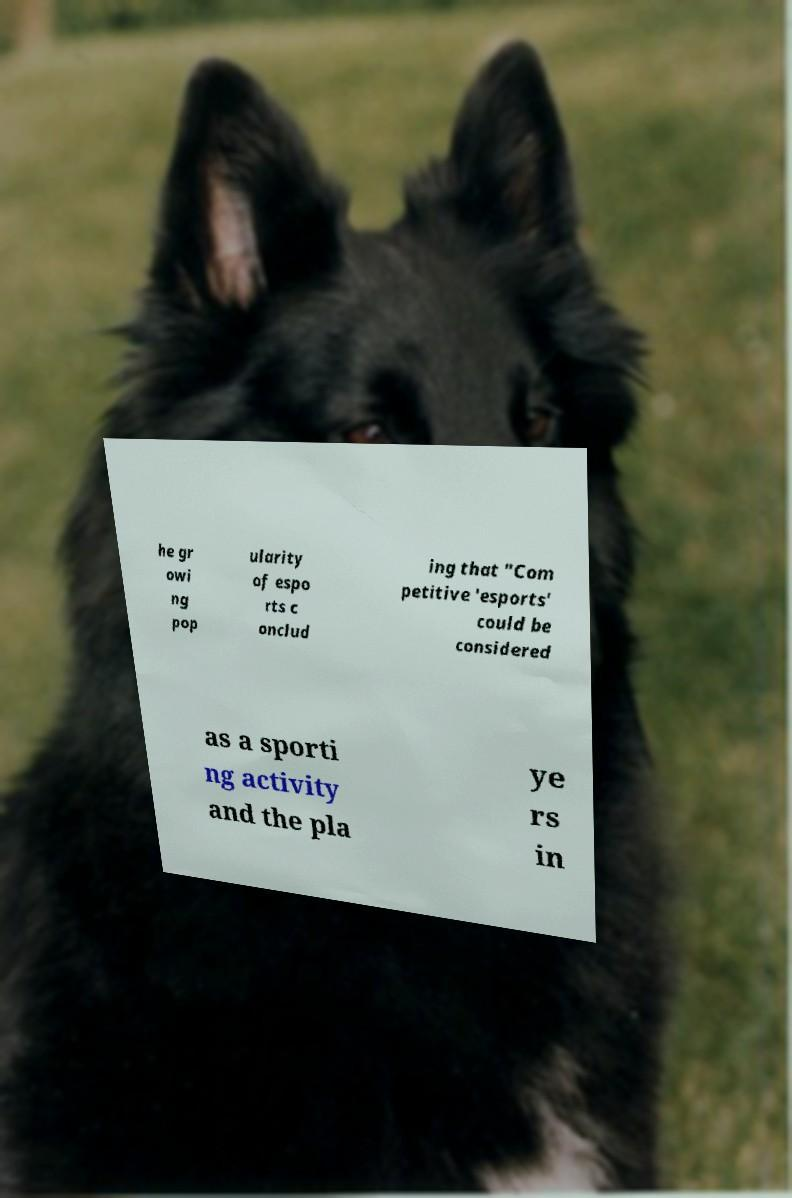Please identify and transcribe the text found in this image. he gr owi ng pop ularity of espo rts c onclud ing that "Com petitive 'esports' could be considered as a sporti ng activity and the pla ye rs in 